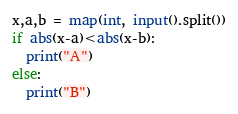<code> <loc_0><loc_0><loc_500><loc_500><_Python_>x,a,b = map(int, input().split())
if abs(x-a)<abs(x-b):
  print("A")
else:
  print("B")</code> 